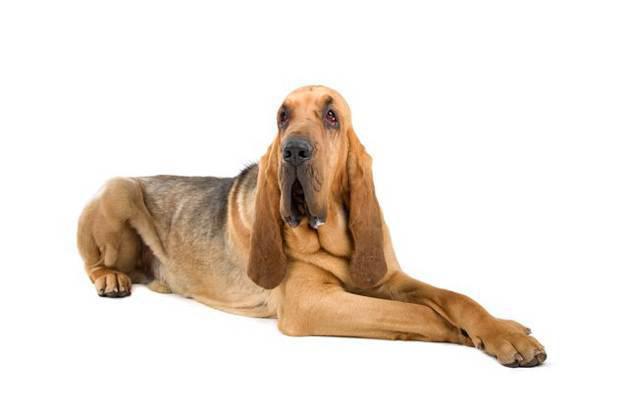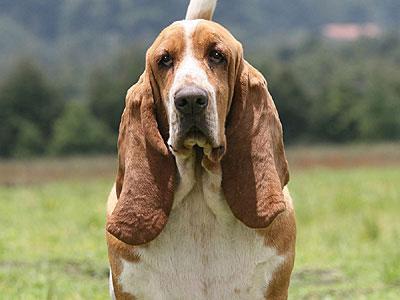The first image is the image on the left, the second image is the image on the right. Examine the images to the left and right. Is the description "The dog in the image on the right is turned toward and facing the camera." accurate? Answer yes or no. Yes. 